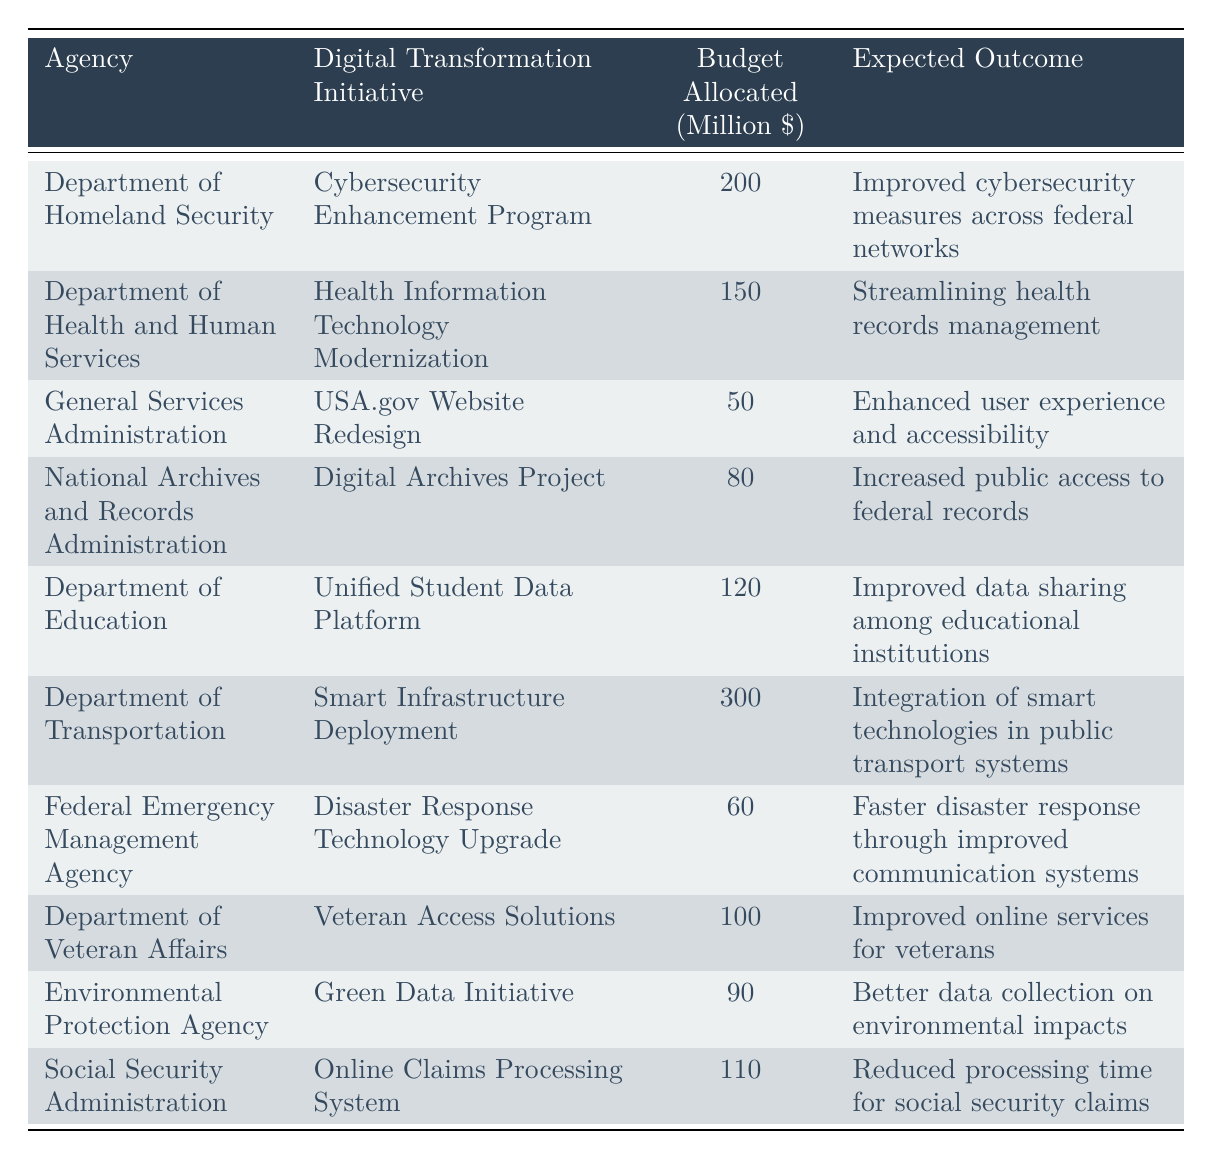What is the budget allocated for the Cybersecurity Enhancement Program? The table lists the Cybersecurity Enhancement Program under the Department of Homeland Security, which has a budget allocated of 200 million dollars in the fiscal year 2023.
Answer: 200 million dollars What is the expected outcome of the Health Information Technology Modernization initiative? According to the table, the expected outcome of the Health Information Technology Modernization initiative by the Department of Health and Human Services is to streamline health records management.
Answer: Streamlining health records management Which agency received the largest budget allocation for 2023? In the table, the largest budget allocation is for the Department of Transportation's Smart Infrastructure Deployment, which has a budget of 300 million dollars.
Answer: Department of Transportation What is the total budget allocated for digital transformation initiatives across all agencies in 2023? To find the total budget, we sum the allocations: 200 + 150 + 50 + 80 + 120 + 300 + 60 + 100 + 90 + 110 = 1,260 million dollars.
Answer: 1,260 million dollars Did the Environmental Protection Agency receive more budget than the General Services Administration? The Environmental Protection Agency's budget is 90 million dollars, while the General Services Administration's budget is 50 million dollars. Since 90 is greater than 50, the Environmental Protection Agency did receive more budget.
Answer: Yes What is the difference in budget between the Digital Archives Project and the Unified Student Data Platform? The budget for the Digital Archives Project is 80 million dollars, and for the Unified Student Data Platform, it is 120 million dollars. The difference is 120 - 80 = 40 million dollars.
Answer: 40 million dollars What percentage of the total budget is allocated to the Online Claims Processing System initiative? The budget for the Online Claims Processing System is 110 million dollars. The total budget was calculated as 1,260 million dollars. To find the percentage, (110 / 1260) * 100 = 8.73%.
Answer: 8.73% Which initiatives have a budget allocation of over 100 million dollars? Referring to the table, the initiatives with over 100 million dollars are: Smart Infrastructure Deployment (300 million), Cybersecurity Enhancement Program (200 million), and Health Information Technology Modernization (150 million).
Answer: Smart Infrastructure Deployment, Cybersecurity Enhancement Program, Health Information Technology Modernization How many initiatives have an expected outcome related to improving public services? The initiatives that improve public services, according to their expected outcomes, are Cybersecurity Enhancement Program, Veteran Access Solutions, and Online Claims Processing System. Counting these, there are three initiatives.
Answer: 3 